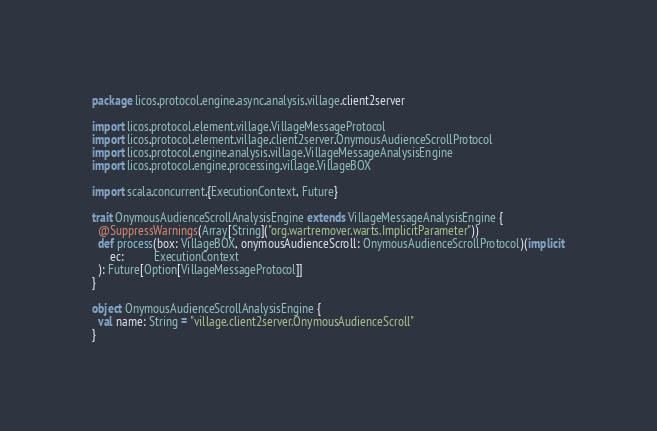<code> <loc_0><loc_0><loc_500><loc_500><_Scala_>package licos.protocol.engine.async.analysis.village.client2server

import licos.protocol.element.village.VillageMessageProtocol
import licos.protocol.element.village.client2server.OnymousAudienceScrollProtocol
import licos.protocol.engine.analysis.village.VillageMessageAnalysisEngine
import licos.protocol.engine.processing.village.VillageBOX

import scala.concurrent.{ExecutionContext, Future}

trait OnymousAudienceScrollAnalysisEngine extends VillageMessageAnalysisEngine {
  @SuppressWarnings(Array[String]("org.wartremover.warts.ImplicitParameter"))
  def process(box: VillageBOX, onymousAudienceScroll: OnymousAudienceScrollProtocol)(implicit
      ec:          ExecutionContext
  ): Future[Option[VillageMessageProtocol]]
}

object OnymousAudienceScrollAnalysisEngine {
  val name: String = "village.client2server.OnymousAudienceScroll"
}
</code> 